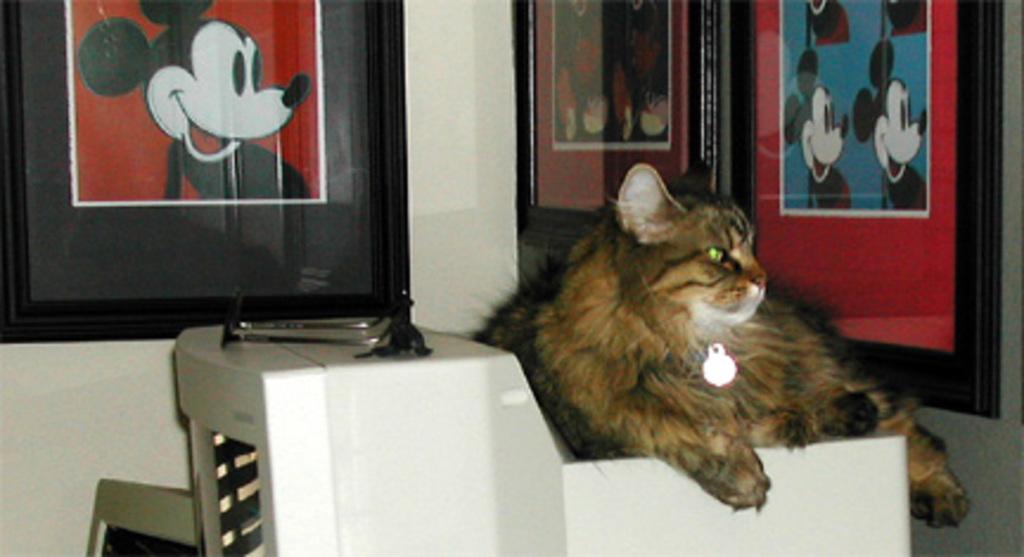Please provide a concise description of this image. In this image, we can see a cat wearing a chain with light and sitting on the stand. In the background, there are frames placed on the wall. 